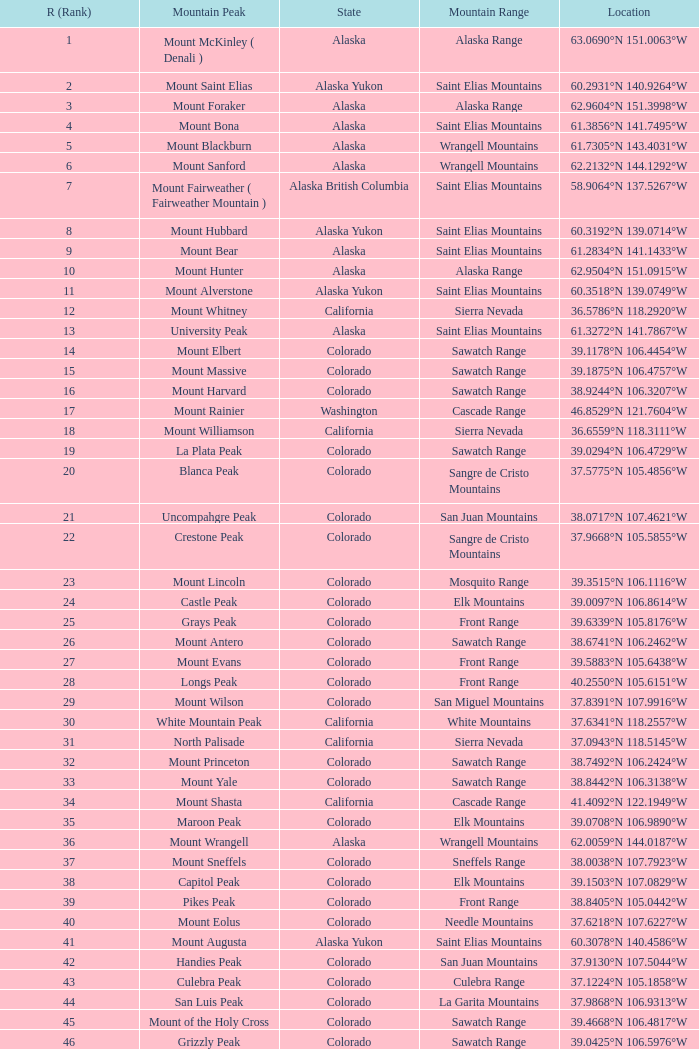What mountain peak can be found at the coordinates 37.5775°n 105.4856°w? Blanca Peak. 